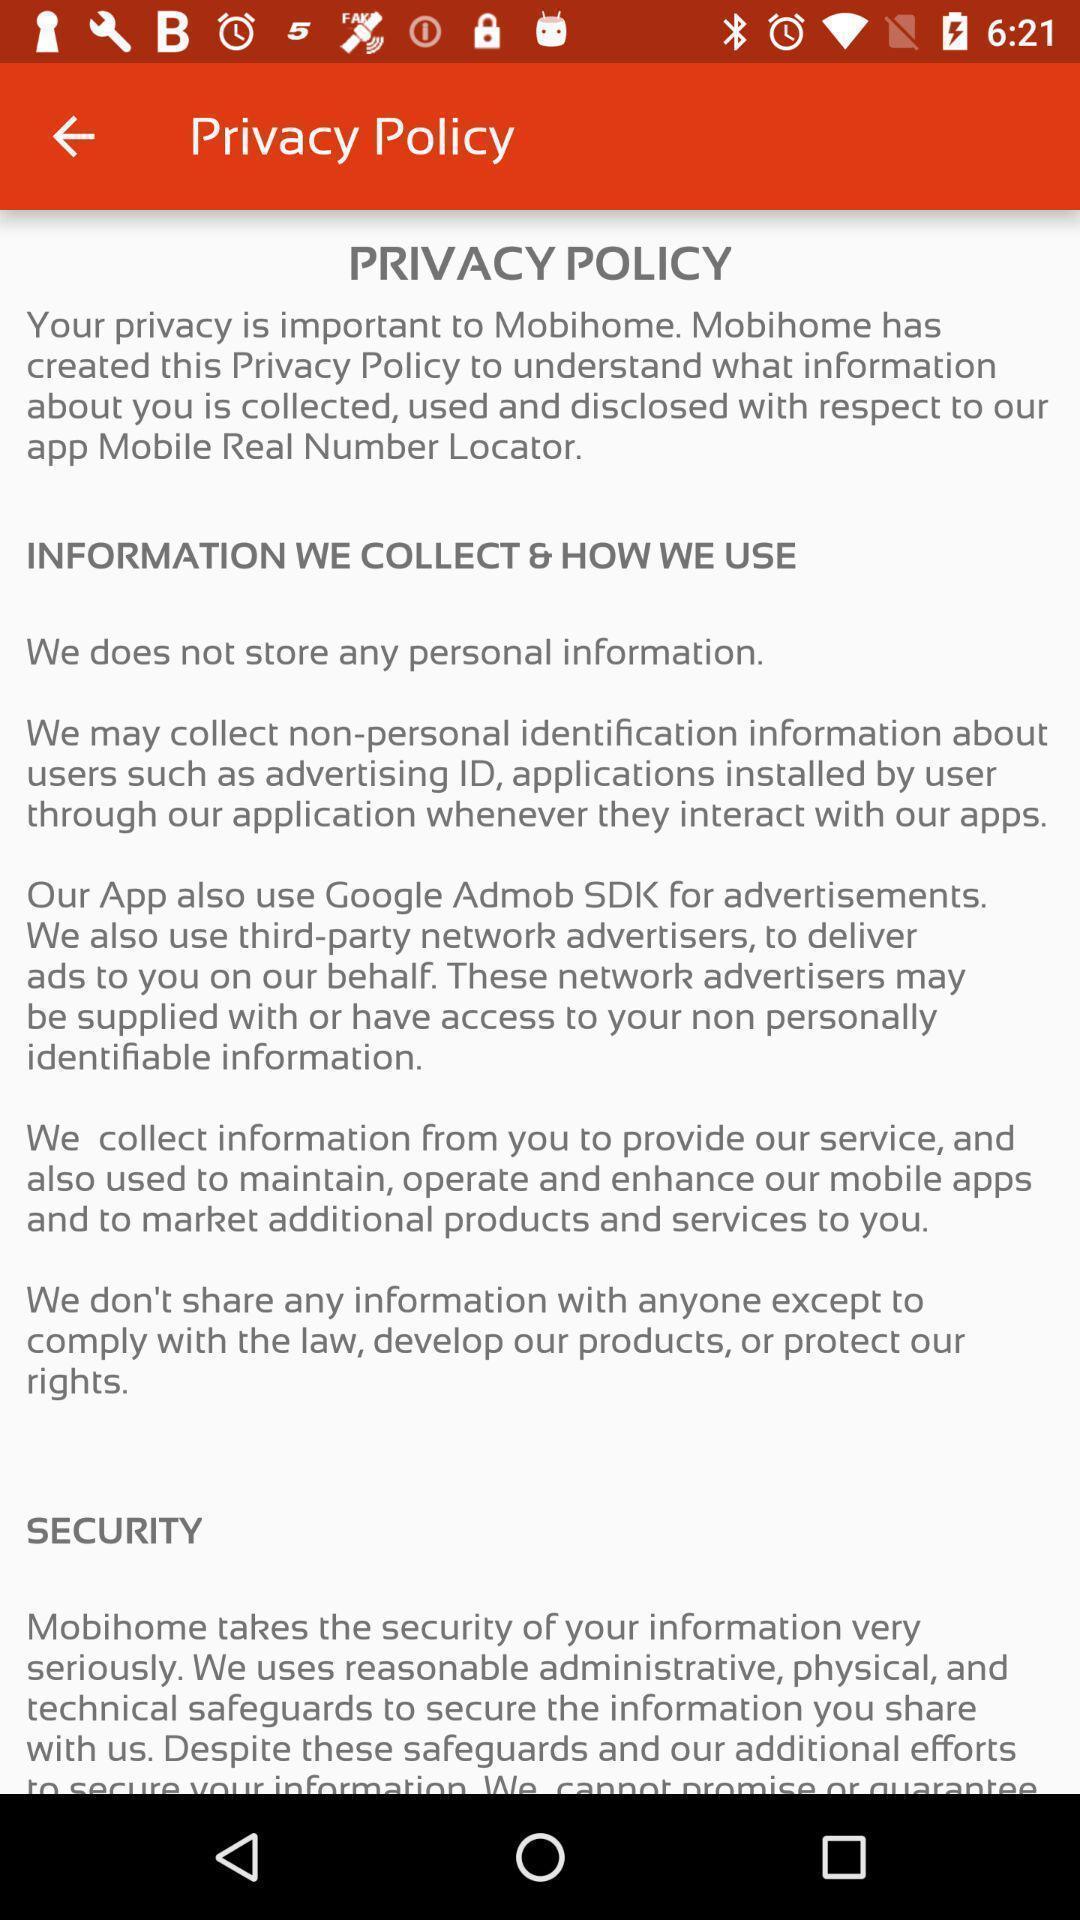Describe the key features of this screenshot. Screen shows information about privacy policies. 